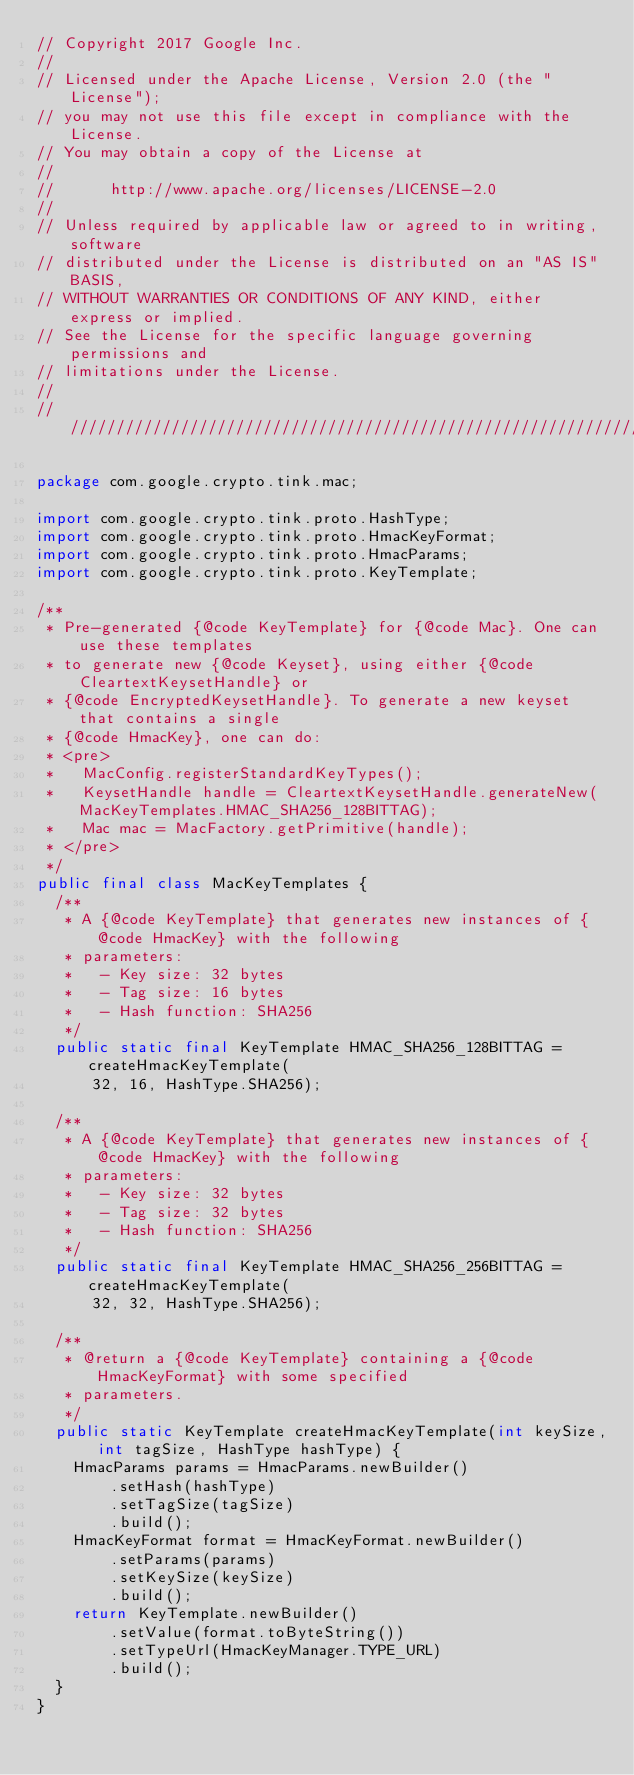Convert code to text. <code><loc_0><loc_0><loc_500><loc_500><_Java_>// Copyright 2017 Google Inc.
//
// Licensed under the Apache License, Version 2.0 (the "License");
// you may not use this file except in compliance with the License.
// You may obtain a copy of the License at
//
//      http://www.apache.org/licenses/LICENSE-2.0
//
// Unless required by applicable law or agreed to in writing, software
// distributed under the License is distributed on an "AS IS" BASIS,
// WITHOUT WARRANTIES OR CONDITIONS OF ANY KIND, either express or implied.
// See the License for the specific language governing permissions and
// limitations under the License.
//
////////////////////////////////////////////////////////////////////////////////

package com.google.crypto.tink.mac;

import com.google.crypto.tink.proto.HashType;
import com.google.crypto.tink.proto.HmacKeyFormat;
import com.google.crypto.tink.proto.HmacParams;
import com.google.crypto.tink.proto.KeyTemplate;

/**
 * Pre-generated {@code KeyTemplate} for {@code Mac}. One can use these templates
 * to generate new {@code Keyset}, using either {@code CleartextKeysetHandle} or
 * {@code EncryptedKeysetHandle}. To generate a new keyset that contains a single
 * {@code HmacKey}, one can do:
 * <pre>
 *   MacConfig.registerStandardKeyTypes();
 *   KeysetHandle handle = CleartextKeysetHandle.generateNew(MacKeyTemplates.HMAC_SHA256_128BITTAG);
 *   Mac mac = MacFactory.getPrimitive(handle);
 * </pre>
 */
public final class MacKeyTemplates {
  /**
   * A {@code KeyTemplate} that generates new instances of {@code HmacKey} with the following
   * parameters:
   *   - Key size: 32 bytes
   *   - Tag size: 16 bytes
   *   - Hash function: SHA256
   */
  public static final KeyTemplate HMAC_SHA256_128BITTAG = createHmacKeyTemplate(
      32, 16, HashType.SHA256);

  /**
   * A {@code KeyTemplate} that generates new instances of {@code HmacKey} with the following
   * parameters:
   *   - Key size: 32 bytes
   *   - Tag size: 32 bytes
   *   - Hash function: SHA256
   */
  public static final KeyTemplate HMAC_SHA256_256BITTAG = createHmacKeyTemplate(
      32, 32, HashType.SHA256);

  /**
   * @return a {@code KeyTemplate} containing a {@code HmacKeyFormat} with some specified
   * parameters.
   */
  public static KeyTemplate createHmacKeyTemplate(int keySize, int tagSize, HashType hashType) {
    HmacParams params = HmacParams.newBuilder()
        .setHash(hashType)
        .setTagSize(tagSize)
        .build();
    HmacKeyFormat format = HmacKeyFormat.newBuilder()
        .setParams(params)
        .setKeySize(keySize)
        .build();
    return KeyTemplate.newBuilder()
        .setValue(format.toByteString())
        .setTypeUrl(HmacKeyManager.TYPE_URL)
        .build();
  }
}
</code> 